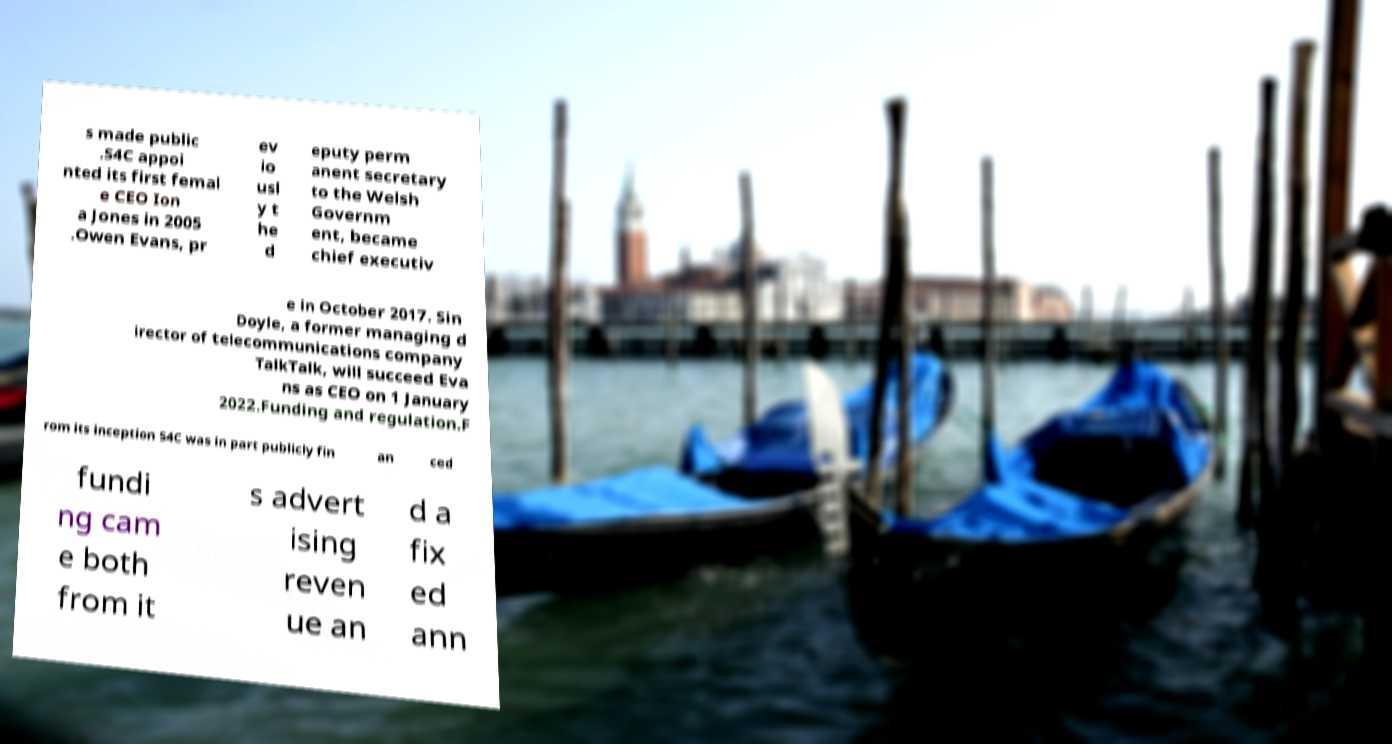Can you read and provide the text displayed in the image?This photo seems to have some interesting text. Can you extract and type it out for me? s made public .S4C appoi nted its first femal e CEO Ion a Jones in 2005 .Owen Evans, pr ev io usl y t he d eputy perm anent secretary to the Welsh Governm ent, became chief executiv e in October 2017. Sin Doyle, a former managing d irector of telecommunications company TalkTalk, will succeed Eva ns as CEO on 1 January 2022.Funding and regulation.F rom its inception S4C was in part publicly fin an ced fundi ng cam e both from it s advert ising reven ue an d a fix ed ann 